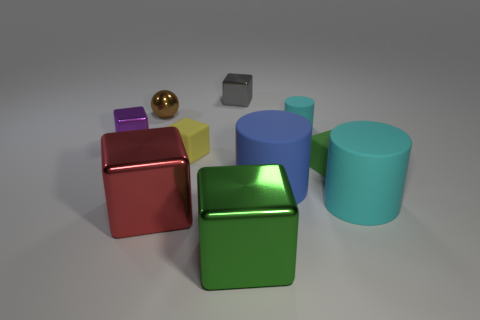Subtract all red blocks. How many blocks are left? 5 Subtract all big green blocks. How many blocks are left? 5 Subtract all cyan cubes. Subtract all purple balls. How many cubes are left? 6 Subtract all blocks. How many objects are left? 4 Add 6 cyan rubber objects. How many cyan rubber objects are left? 8 Add 7 big yellow things. How many big yellow things exist? 7 Subtract 0 purple spheres. How many objects are left? 10 Subtract all large red metallic objects. Subtract all tiny matte cylinders. How many objects are left? 8 